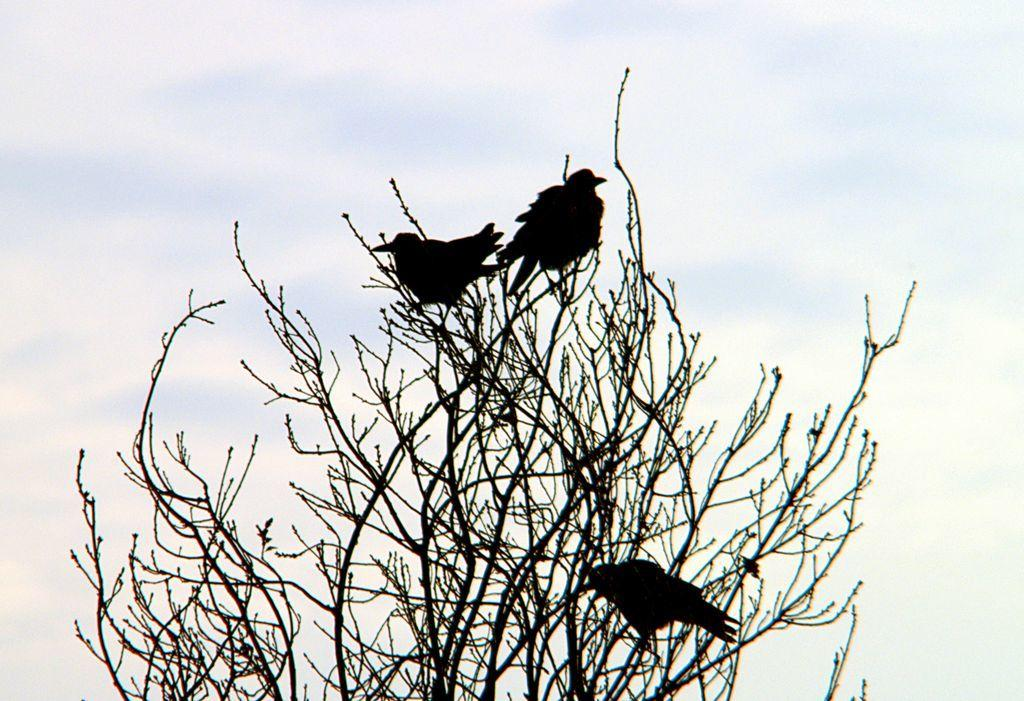How many birds are in the image? There are three birds in the image. Where are the birds located? The birds are sitting on a tree. Can you describe the tree in the image? The tree is visible in the bottom of the image. What can be seen in the background of the image? The sky is visible in the background of the image. What type of bead is hanging from the tree in the image? There is no bead present in the image; it features three birds sitting on a tree. Can you see a van driving across the bridge in the image? There is no van or bridge present in the image; it only shows three birds sitting on a tree and the sky in the background. 